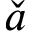Convert formula to latex. <formula><loc_0><loc_0><loc_500><loc_500>\check { a }</formula> 